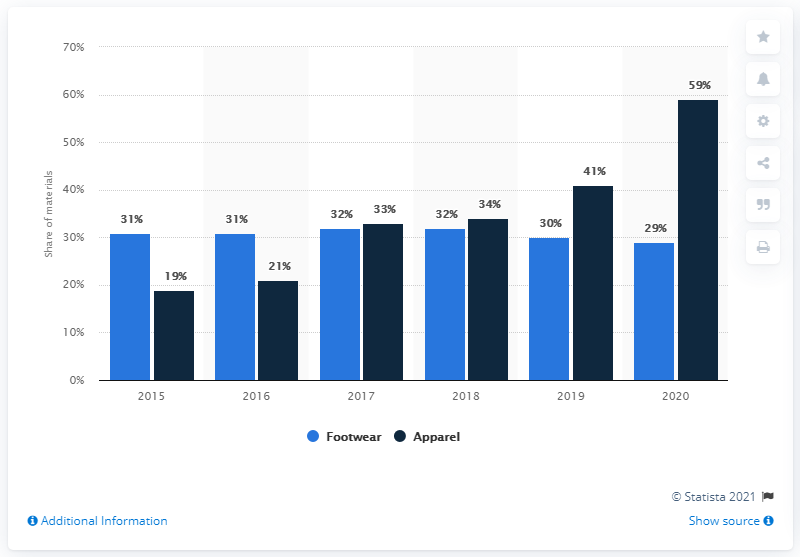Draw attention to some important aspects in this diagram. The value of the highest bar is 59. The sum of the highest and lowest bars in the chart is 78. In 2015, it was determined that a significant percentage of apparel used more sustainable materials. Specifically, the percentage of sustainable materials used in apparel was 19%. This represents a significant step forward in the effort to create more environmentally friendly clothing options. In 2015, the amount of sustainable materials used in footwear was 19.. 